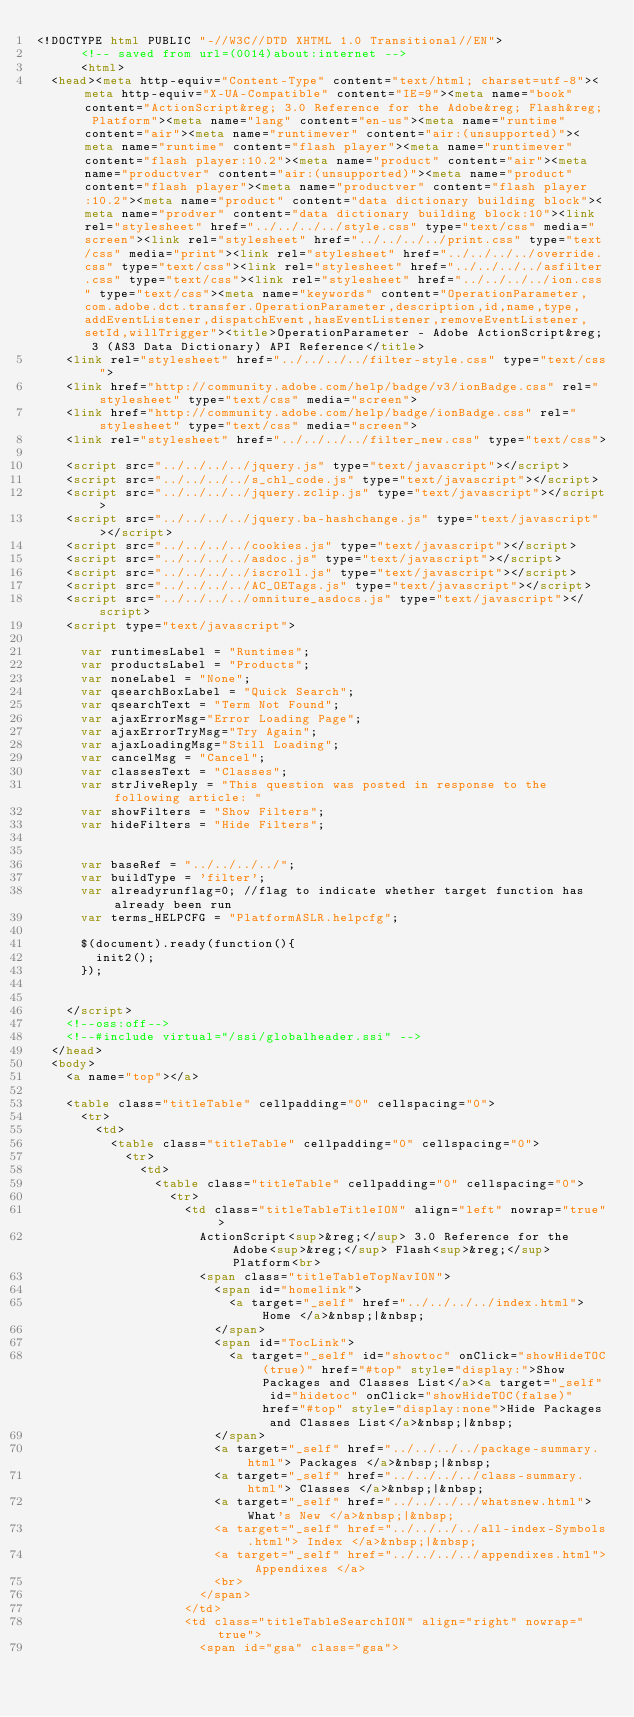Convert code to text. <code><loc_0><loc_0><loc_500><loc_500><_HTML_><!DOCTYPE html PUBLIC "-//W3C//DTD XHTML 1.0 Transitional//EN">
			<!-- saved from url=(0014)about:internet -->
			<html>
	<head><meta http-equiv="Content-Type" content="text/html; charset=utf-8"><meta http-equiv="X-UA-Compatible" content="IE=9"><meta name="book" content="ActionScript&reg; 3.0 Reference for the Adobe&reg; Flash&reg; Platform"><meta name="lang" content="en-us"><meta name="runtime" content="air"><meta name="runtimever" content="air:(unsupported)"><meta name="runtime" content="flash player"><meta name="runtimever" content="flash player:10.2"><meta name="product" content="air"><meta name="productver" content="air:(unsupported)"><meta name="product" content="flash player"><meta name="productver" content="flash player:10.2"><meta name="product" content="data dictionary building block"><meta name="prodver" content="data dictionary building block:10"><link rel="stylesheet" href="../../../../style.css" type="text/css" media="screen"><link rel="stylesheet" href="../../../../print.css" type="text/css" media="print"><link rel="stylesheet" href="../../../../override.css" type="text/css"><link rel="stylesheet" href="../../../../asfilter.css" type="text/css"><link rel="stylesheet" href="../../../../ion.css" type="text/css"><meta name="keywords" content="OperationParameter,com.adobe.dct.transfer.OperationParameter,description,id,name,type,addEventListener,dispatchEvent,hasEventListener,removeEventListener,setId,willTrigger"><title>OperationParameter - Adobe ActionScript&reg; 3 (AS3 Data Dictionary) API Reference</title>
		<link rel="stylesheet" href="../../../../filter-style.css" type="text/css">
		<link href="http://community.adobe.com/help/badge/v3/ionBadge.css" rel="stylesheet" type="text/css" media="screen">
		<link href="http://community.adobe.com/help/badge/ionBadge.css" rel="stylesheet" type="text/css" media="screen">
		<link rel="stylesheet" href="../../../../filter_new.css" type="text/css">
			
		<script src="../../../../jquery.js" type="text/javascript"></script>
		<script src="../../../../s_chl_code.js" type="text/javascript"></script>
		<script src="../../../../jquery.zclip.js" type="text/javascript"></script>
		<script src="../../../../jquery.ba-hashchange.js" type="text/javascript"></script>
		<script src="../../../../cookies.js" type="text/javascript"></script>
		<script src="../../../../asdoc.js" type="text/javascript"></script>
		<script src="../../../../iscroll.js" type="text/javascript"></script>
		<script src="../../../../AC_OETags.js" type="text/javascript"></script>
		<script src="../../../../omniture_asdocs.js" type="text/javascript"></script>
		<script type="text/javascript">
		
			var runtimesLabel = "Runtimes";
			var productsLabel = "Products";
			var noneLabel = "None";
			var qsearchBoxLabel = "Quick Search";
			var qsearchText = "Term Not Found";
			var ajaxErrorMsg="Error Loading Page";
			var ajaxErrorTryMsg="Try Again";
			var ajaxLoadingMsg="Still Loading";
			var cancelMsg = "Cancel";
			var classesText = "Classes";
			var strJiveReply = "This question was posted in response to the following article: "
			var showFilters = "Show Filters";
			var hideFilters = "Hide Filters";
			
		
			var baseRef = "../../../../";
			var buildType = 'filter';
			var alreadyrunflag=0; //flag to indicate whether target function has already been run
			var terms_HELPCFG = "PlatformASLR.helpcfg";
			
			$(document).ready(function(){
				init2();
			});
			
		
		</script>
		<!--oss:off-->
		<!--#include virtual="/ssi/globalheader.ssi" -->
	</head>
	<body>
		<a name="top"></a>
		
		<table class="titleTable" cellpadding="0" cellspacing="0">
			<tr>
				<td>
					<table class="titleTable" cellpadding="0" cellspacing="0">
						<tr>
							<td>
								<table class="titleTable" cellpadding="0" cellspacing="0">
									<tr>
										<td class="titleTableTitleION" align="left" nowrap="true">
											ActionScript<sup>&reg;</sup> 3.0 Reference for the Adobe<sup>&reg;</sup> Flash<sup>&reg;</sup> Platform<br>
											<span class="titleTableTopNavION">
												<span id="homelink">
													<a target="_self" href="../../../../index.html"> Home </a>&nbsp;|&nbsp;
												</span>
												<span id="TocLink">
													<a target="_self" id="showtoc" onClick="showHideTOC(true)" href="#top" style="display:">Show Packages and Classes List</a><a target="_self" id="hidetoc" onClick="showHideTOC(false)" href="#top" style="display:none">Hide Packages and Classes List</a>&nbsp;|&nbsp;
												</span>
												<a target="_self" href="../../../../package-summary.html"> Packages </a>&nbsp;|&nbsp;
												<a target="_self" href="../../../../class-summary.html"> Classes </a>&nbsp;|&nbsp;
												<a target="_self" href="../../../../whatsnew.html"> What's New </a>&nbsp;|&nbsp;
												<a target="_self" href="../../../../all-index-Symbols.html"> Index </a>&nbsp;|&nbsp;
												<a target="_self" href="../../../../appendixes.html"> Appendixes </a>
												<br>
											</span>	
										</td>
										<td class="titleTableSearchION" align="right" nowrap="true">
											<span id="gsa" class="gsa"></code> 